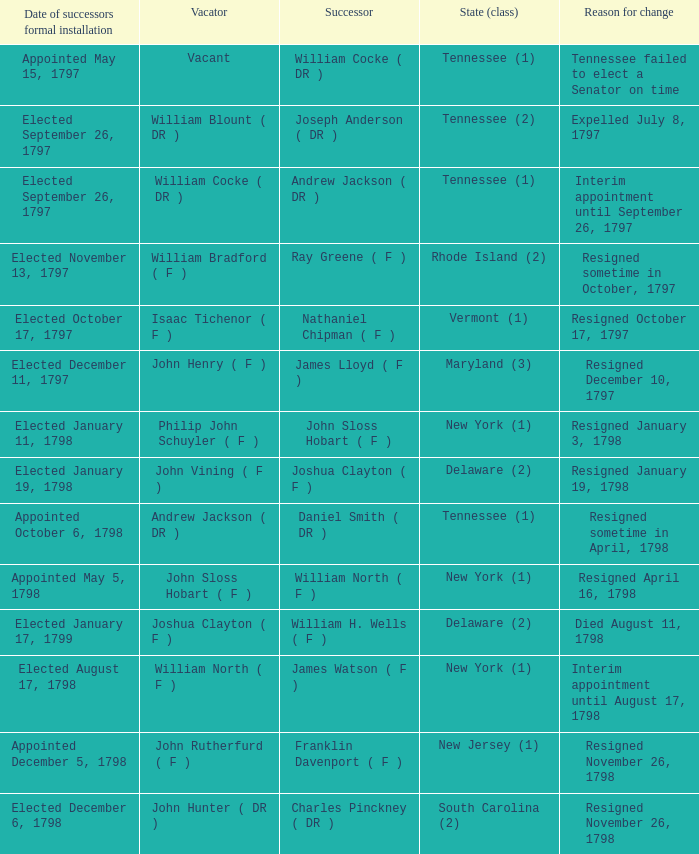Write the full table. {'header': ['Date of successors formal installation', 'Vacator', 'Successor', 'State (class)', 'Reason for change'], 'rows': [['Appointed May 15, 1797', 'Vacant', 'William Cocke ( DR )', 'Tennessee (1)', 'Tennessee failed to elect a Senator on time'], ['Elected September 26, 1797', 'William Blount ( DR )', 'Joseph Anderson ( DR )', 'Tennessee (2)', 'Expelled July 8, 1797'], ['Elected September 26, 1797', 'William Cocke ( DR )', 'Andrew Jackson ( DR )', 'Tennessee (1)', 'Interim appointment until September 26, 1797'], ['Elected November 13, 1797', 'William Bradford ( F )', 'Ray Greene ( F )', 'Rhode Island (2)', 'Resigned sometime in October, 1797'], ['Elected October 17, 1797', 'Isaac Tichenor ( F )', 'Nathaniel Chipman ( F )', 'Vermont (1)', 'Resigned October 17, 1797'], ['Elected December 11, 1797', 'John Henry ( F )', 'James Lloyd ( F )', 'Maryland (3)', 'Resigned December 10, 1797'], ['Elected January 11, 1798', 'Philip John Schuyler ( F )', 'John Sloss Hobart ( F )', 'New York (1)', 'Resigned January 3, 1798'], ['Elected January 19, 1798', 'John Vining ( F )', 'Joshua Clayton ( F )', 'Delaware (2)', 'Resigned January 19, 1798'], ['Appointed October 6, 1798', 'Andrew Jackson ( DR )', 'Daniel Smith ( DR )', 'Tennessee (1)', 'Resigned sometime in April, 1798'], ['Appointed May 5, 1798', 'John Sloss Hobart ( F )', 'William North ( F )', 'New York (1)', 'Resigned April 16, 1798'], ['Elected January 17, 1799', 'Joshua Clayton ( F )', 'William H. Wells ( F )', 'Delaware (2)', 'Died August 11, 1798'], ['Elected August 17, 1798', 'William North ( F )', 'James Watson ( F )', 'New York (1)', 'Interim appointment until August 17, 1798'], ['Appointed December 5, 1798', 'John Rutherfurd ( F )', 'Franklin Davenport ( F )', 'New Jersey (1)', 'Resigned November 26, 1798'], ['Elected December 6, 1798', 'John Hunter ( DR )', 'Charles Pinckney ( DR )', 'South Carolina (2)', 'Resigned November 26, 1798']]} What is the total number of dates of successor formal installation when the vacator was Joshua Clayton ( F )? 1.0. 